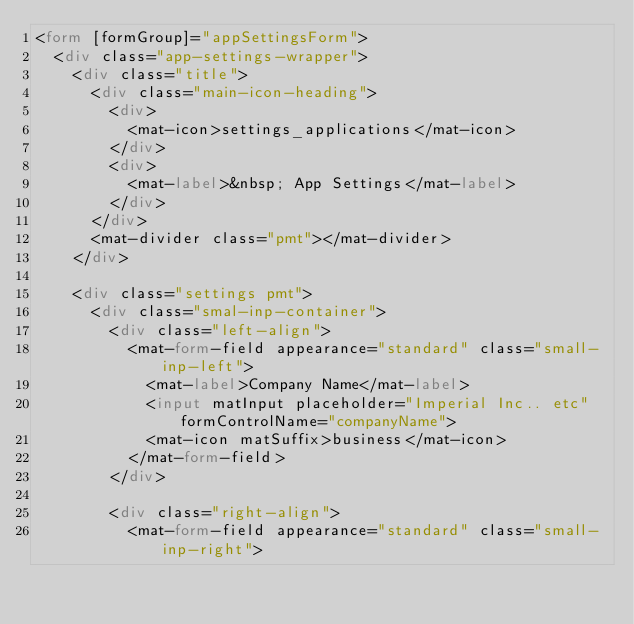<code> <loc_0><loc_0><loc_500><loc_500><_HTML_><form [formGroup]="appSettingsForm">
  <div class="app-settings-wrapper">
    <div class="title">
      <div class="main-icon-heading">
        <div>
          <mat-icon>settings_applications</mat-icon>
        </div>
        <div>
          <mat-label>&nbsp; App Settings</mat-label>
        </div>
      </div>
      <mat-divider class="pmt"></mat-divider>
    </div>

    <div class="settings pmt">
      <div class="smal-inp-container">
        <div class="left-align">
          <mat-form-field appearance="standard" class="small-inp-left">
            <mat-label>Company Name</mat-label>
            <input matInput placeholder="Imperial Inc.. etc" formControlName="companyName">
            <mat-icon matSuffix>business</mat-icon>
          </mat-form-field>
        </div>

        <div class="right-align">
          <mat-form-field appearance="standard" class="small-inp-right"></code> 